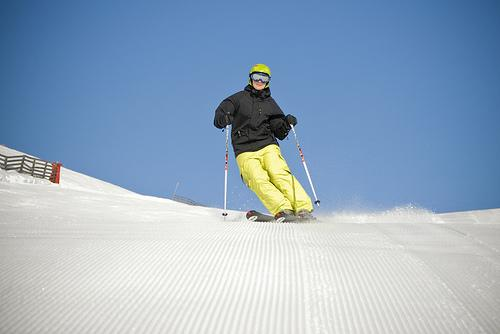What type of facial gear is the man wearing, and what color is it? The man is wearing gray and blue ski goggles on his face. Describe the surface on which the person is skiing. The person is skiing on a well-groomed ski slope, with thin lines in the snow and some snow being kicked up from the skis. Identify any objects present in the image related to skiing. Downhill skis, ski poles with red and black accents, ski goggles, ski helmet, and ski jacket. Provide a brief description of the main activity taking place in the image. A man wearing a ski suit is downhill skiing on a well-groomed slope, holding ski poles and wearing ski goggles. Mention the type of image, time it was taken, and any distinctive weather conditions. The image is outdoors, taken during the day and features a bright, blue sky with no clouds and a thick coat of snow on the ground. In the image, describe any fenced area and its colors. There is a section of brown fence with a bright red section on the end in the image. How many different types of clothing and gear are the person wearing in the image, and what colors are they? The person is wearing a black ski jacket, yellow ski pants, ski goggles, a yellow ski helmet, a black jacket, black gloves, and ski shoes. What type and color of ski helmet is the person wearing in the image? The person is wearing a yellow ski helmet with a black strap. What are some notable details about the ski poles in the image? The ski poles are silver and red, and also have white, black, and red accents. Describe the setting and environment of the image. The image is set on a well-groomed ski slope, with a bright blue sky, snow-covered mountain, and a small section of gray and red snow fence. 